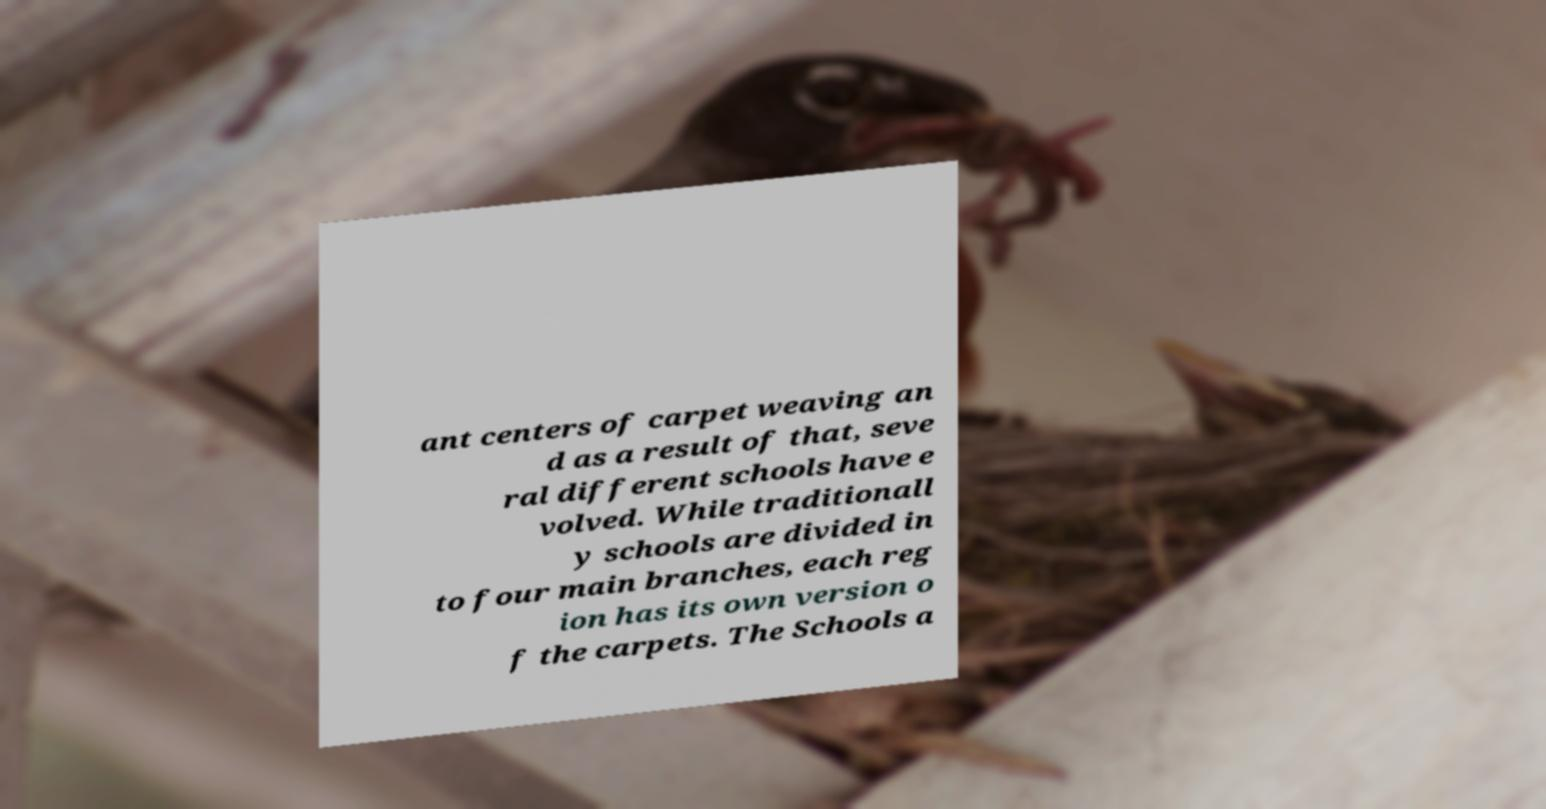I need the written content from this picture converted into text. Can you do that? ant centers of carpet weaving an d as a result of that, seve ral different schools have e volved. While traditionall y schools are divided in to four main branches, each reg ion has its own version o f the carpets. The Schools a 